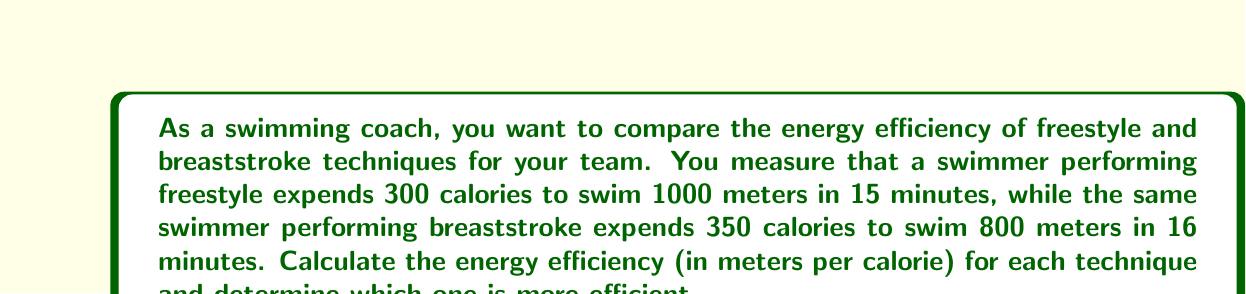Can you solve this math problem? To solve this problem, we need to calculate the energy efficiency for each swimming technique. Energy efficiency in this context can be defined as the distance traveled per unit of energy expended, measured in meters per calorie.

Let's calculate the efficiency for each technique:

1. Freestyle:
   - Distance: 1000 meters
   - Energy expended: 300 calories
   
   Efficiency = $\frac{\text{Distance}}{\text{Energy}}$
   
   $E_f = \frac{1000 \text{ m}}{300 \text{ cal}} = \frac{10}{3} \approx 3.33 \text{ m/cal}$

2. Breaststroke:
   - Distance: 800 meters
   - Energy expended: 350 calories
   
   Efficiency = $\frac{\text{Distance}}{\text{Energy}}$
   
   $E_b = \frac{800 \text{ m}}{350 \text{ cal}} = \frac{16}{7} \approx 2.29 \text{ m/cal}$

To compare the efficiencies:

$E_f - E_b = \frac{10}{3} - \frac{16}{7} = \frac{70}{21} - \frac{48}{21} = \frac{22}{21} \approx 1.05 \text{ m/cal}$

Since the difference is positive, freestyle is more efficient than breaststroke.

We can also calculate the percentage difference in efficiency:

Percentage difference = $\frac{E_f - E_b}{E_b} \times 100\% = \frac{\frac{10}{3} - \frac{16}{7}}{\frac{16}{7}} \times 100\% \approx 45.8\%$

This means freestyle is approximately 45.8% more efficient than breaststroke for this swimmer.
Answer: Freestyle efficiency: $\frac{10}{3} \approx 3.33 \text{ m/cal}$
Breaststroke efficiency: $\frac{16}{7} \approx 2.29 \text{ m/cal}$
Freestyle is more efficient, with approximately 45.8% higher efficiency than breaststroke. 